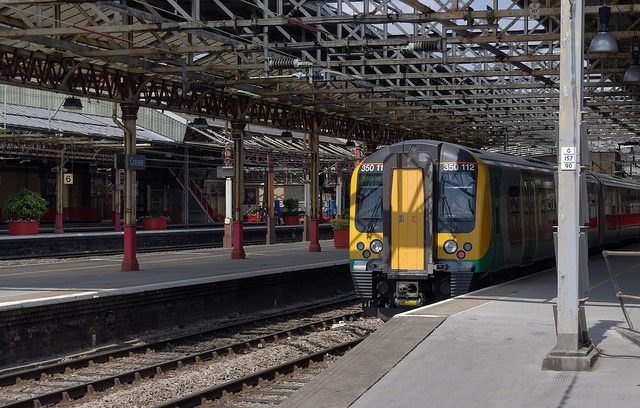Describe the objects in this image and their specific colors. I can see train in gray, black, olive, and orange tones, potted plant in gray, black, maroon, and darkgreen tones, potted plant in gray, black, and maroon tones, potted plant in gray, maroon, black, and darkgreen tones, and potted plant in gray, black, and maroon tones in this image. 